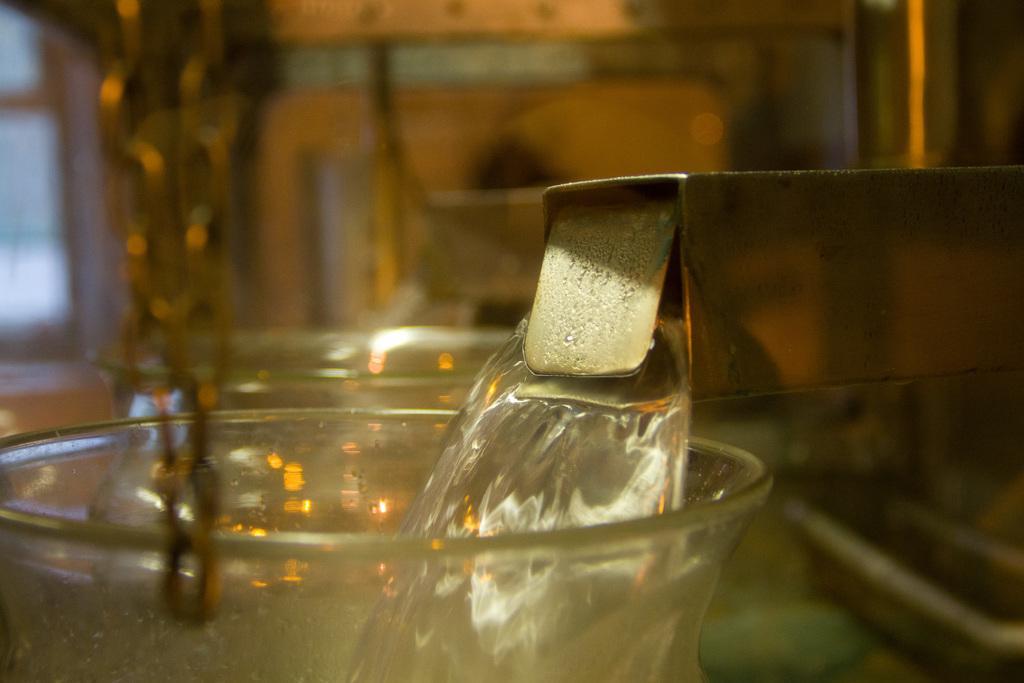How would you summarize this image in a sentence or two? In this image we can see a glass tumbler and beverage. 